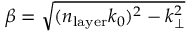Convert formula to latex. <formula><loc_0><loc_0><loc_500><loc_500>\beta = \sqrt { ( n _ { l a y e r } k _ { 0 } ) ^ { 2 } - k _ { \perp } ^ { 2 } }</formula> 